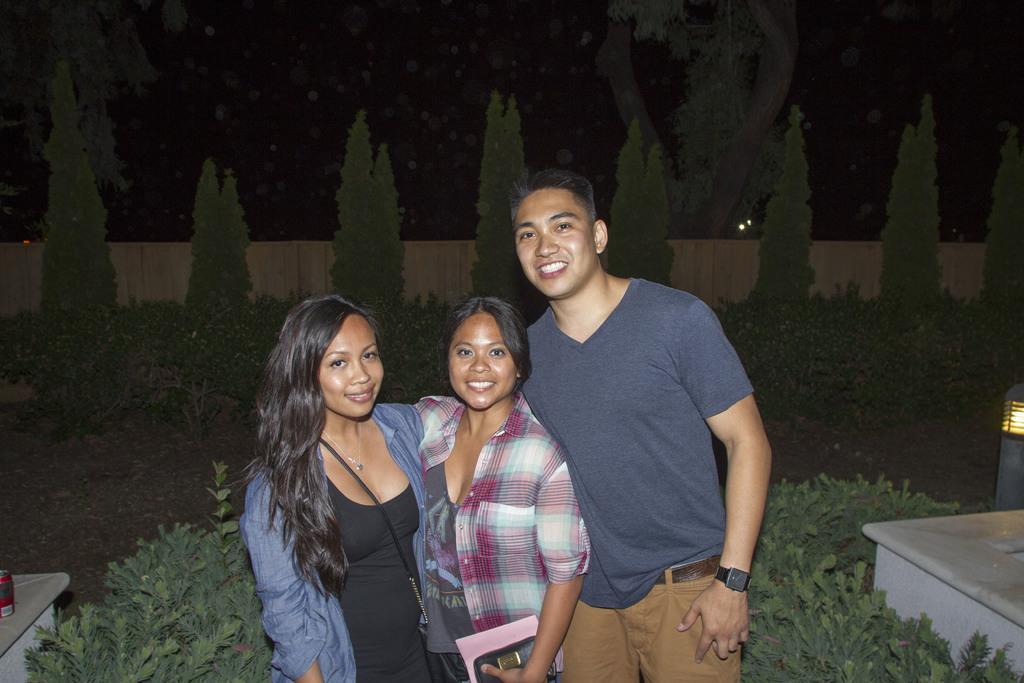Describe this image in one or two sentences. In the image there are three people standing and posing for the photo and behind them there are many plants and trees, behind the trees there is a fencing and it looks like some painting in their background. 